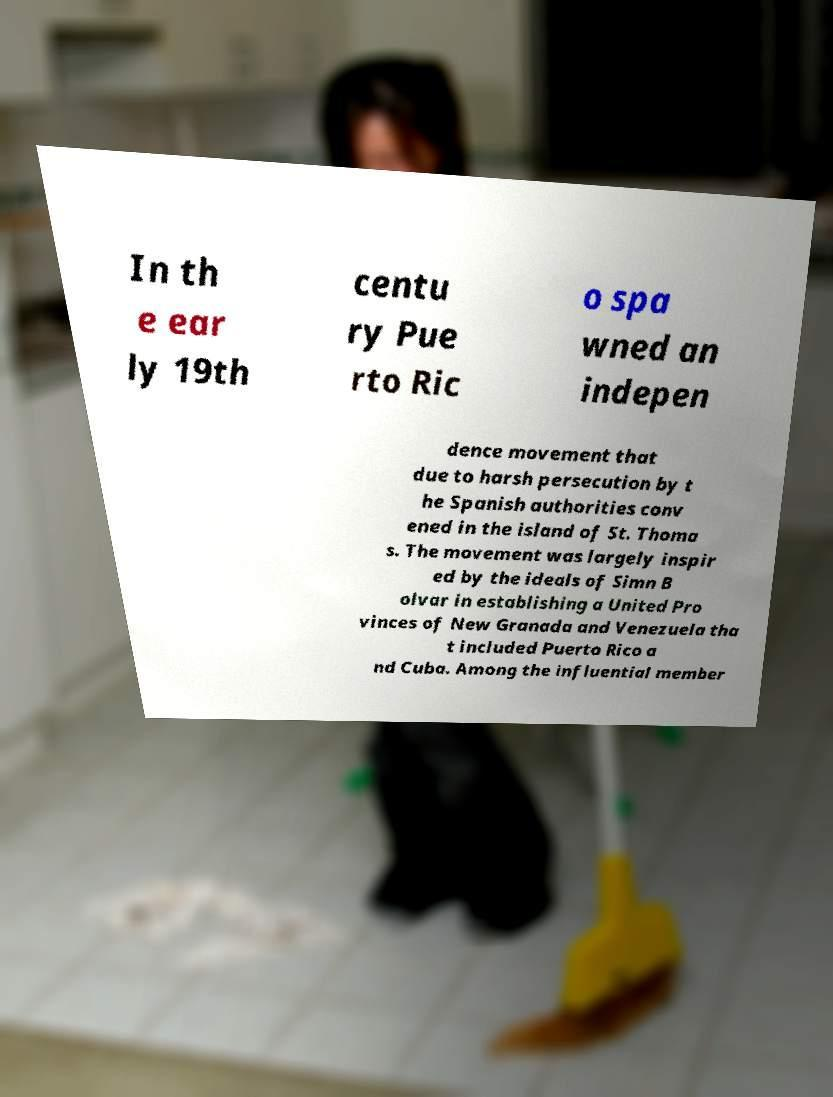Can you accurately transcribe the text from the provided image for me? In th e ear ly 19th centu ry Pue rto Ric o spa wned an indepen dence movement that due to harsh persecution by t he Spanish authorities conv ened in the island of St. Thoma s. The movement was largely inspir ed by the ideals of Simn B olvar in establishing a United Pro vinces of New Granada and Venezuela tha t included Puerto Rico a nd Cuba. Among the influential member 